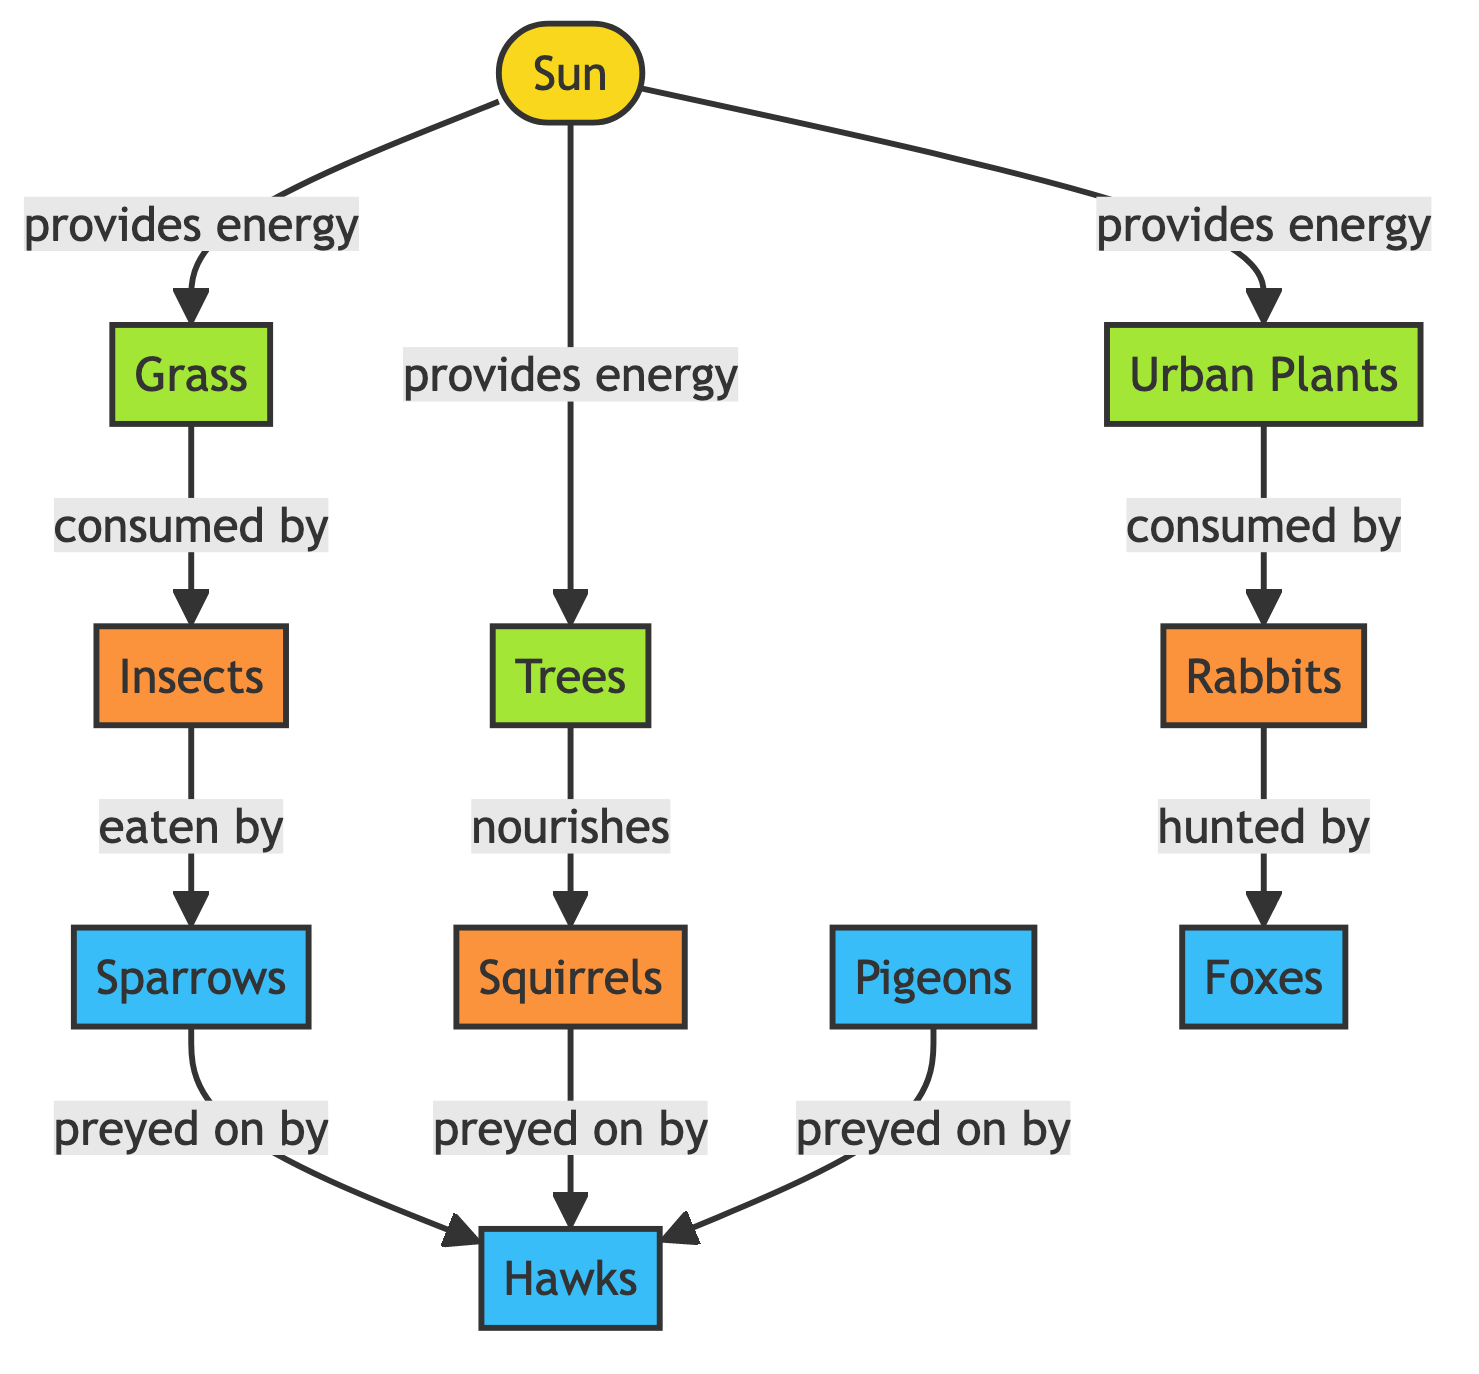What is the primary energy source in the urban food chain? The diagram labels the sun as providing energy, which is indicated by arrows pointing from the sun to various plants such as grass, trees, and urban plants. Thus, the sun is the primary energy source for the food chain.
Answer: Sun How many quaternary consumers are listed in the diagram? The diagram shows four quaternary consumers: sparrows, pigeons, hawks, and foxes. By counting the individual nodes marked as quaternary, we identify the total number. Therefore, there are four quaternary consumers.
Answer: 4 What do insects consume in this food chain? The diagram explicitly shows an arrow from grass to insects with the label "consumed by," indicating that insects feed on grass. Analyzing the flow, the answer is derived directly from this relationship.
Answer: Grass Which organism is directly preyed on by hawks? The diagram lists multiple arrows pointing to hawks, including those for sparrows, squirrels, and pigeons. Since the question specifies "directly preyed on," we focus on the nodes that have arrows pointing towards hawks, and we find three: sparrows, squirrels, and pigeons. The answer confirms the relationship presented in the diagram.
Answer: Sparrows, Squirrels, Pigeons What primary source nourishes squirrels? The diagram indicates that trees nourish squirrels with a direct arrow showing the relationship, written as "nourishes." Thus, the answer reflects directly what is stated in the visual representation.
Answer: Trees Which consumer is involved in the relationship that involves rabbits? The diagram shows an arrow from urban plants to rabbits, labeled "consumed by." Following this, there is another arrow from rabbits pointing to foxes with the label "hunted by." Therefore, the consumer associated with rabbits is foxes, representing their predator in the food chain.
Answer: Foxes What type of organisms are classified as secondary consumers in the diagram? By examining the colors and labels in the diagram, secondary consumers can be identified by looking at the nodes that are not primary producers but feed on them. The tertiary consumers, which feed on primary consumers like insects, include organisms such as sparrows and squirrels. Therefore, the secondary consumers identified here are the ones that are above producers and below tertiary.
Answer: Insects, Rabbits How many nodes directly receive energy from the sun? Counting the arrows leading from the sun, we see it points to three organisms (grass, trees, urban plants). Each is classified as a primary producer receiving energy directly from the sun. Thus, the total number of nodes receiving energy directly is found by simply counting these connections.
Answer: 3 